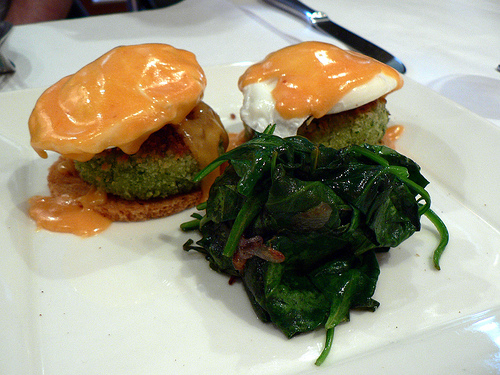<image>
Is the spinach on the plate? Yes. Looking at the image, I can see the spinach is positioned on top of the plate, with the plate providing support. 